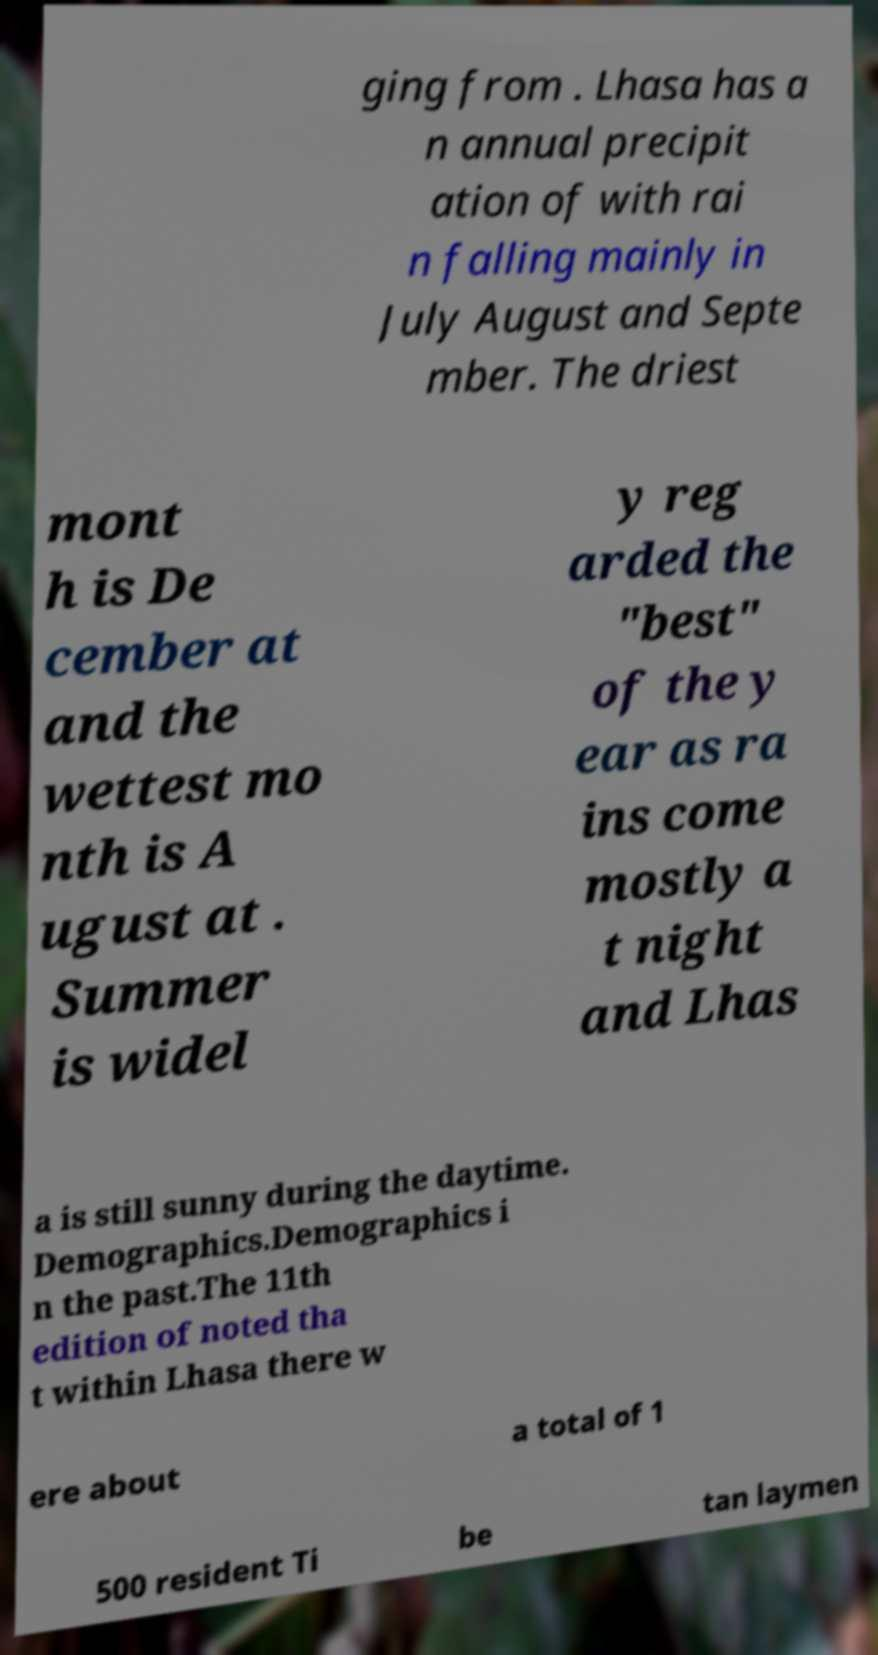There's text embedded in this image that I need extracted. Can you transcribe it verbatim? ging from . Lhasa has a n annual precipit ation of with rai n falling mainly in July August and Septe mber. The driest mont h is De cember at and the wettest mo nth is A ugust at . Summer is widel y reg arded the "best" of the y ear as ra ins come mostly a t night and Lhas a is still sunny during the daytime. Demographics.Demographics i n the past.The 11th edition of noted tha t within Lhasa there w ere about a total of 1 500 resident Ti be tan laymen 